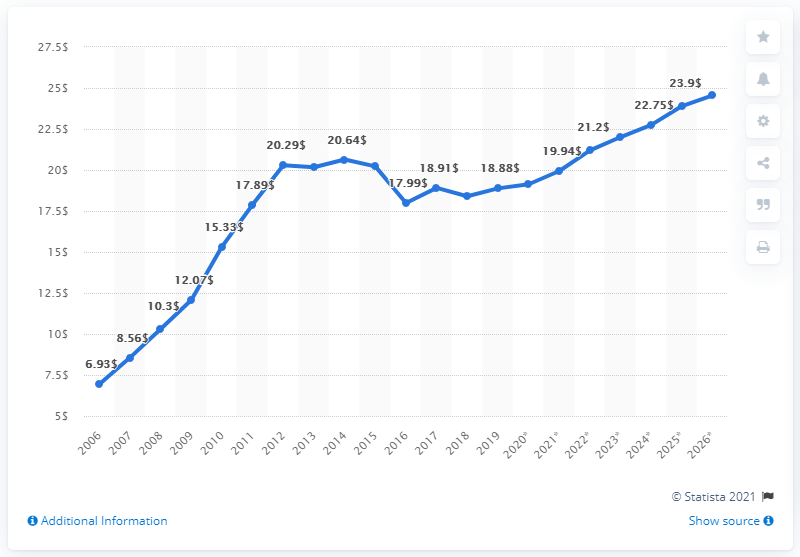List a handful of essential elements in this visual. In 2006, Afghanistan's Gross Domestic Product (GDP) was first measured. 